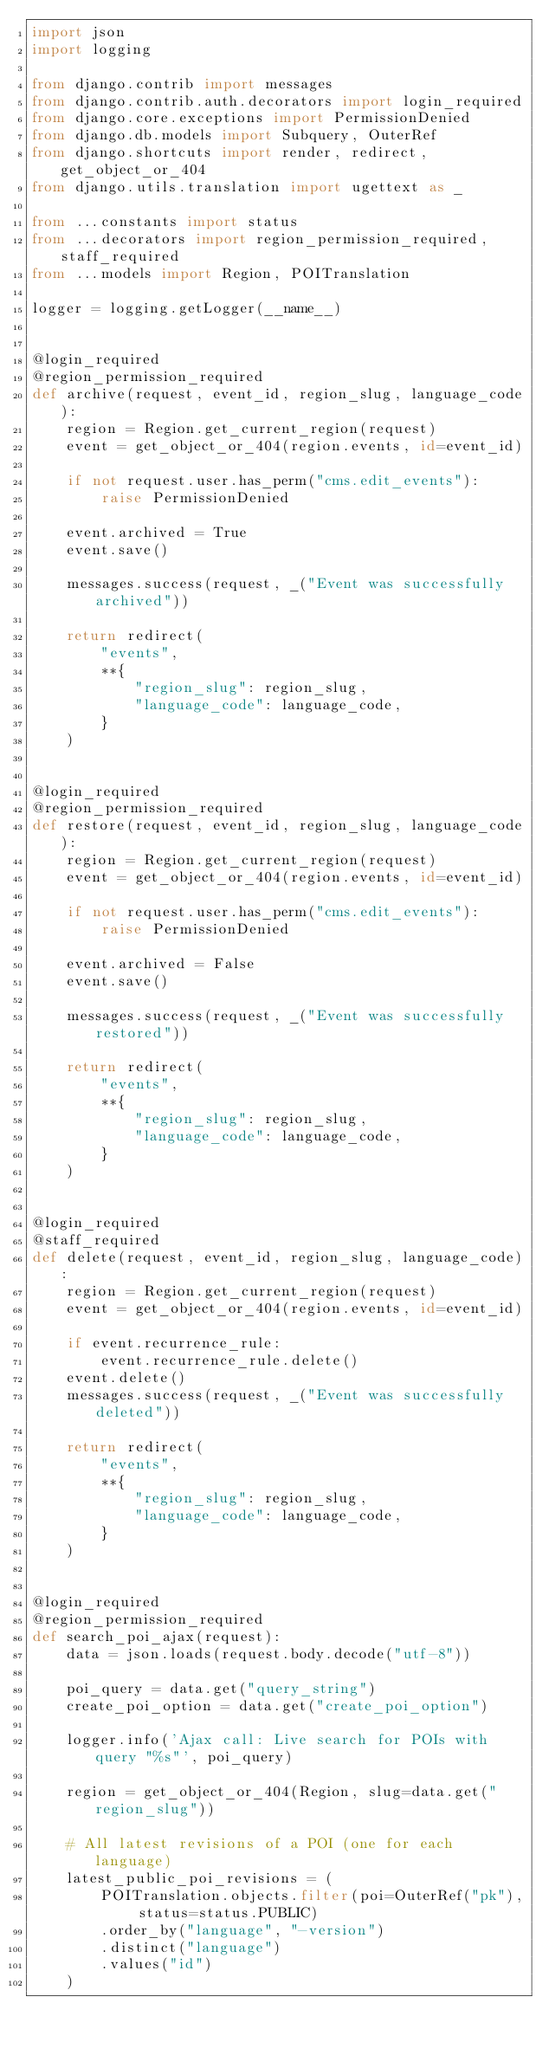<code> <loc_0><loc_0><loc_500><loc_500><_Python_>import json
import logging

from django.contrib import messages
from django.contrib.auth.decorators import login_required
from django.core.exceptions import PermissionDenied
from django.db.models import Subquery, OuterRef
from django.shortcuts import render, redirect, get_object_or_404
from django.utils.translation import ugettext as _

from ...constants import status
from ...decorators import region_permission_required, staff_required
from ...models import Region, POITranslation

logger = logging.getLogger(__name__)


@login_required
@region_permission_required
def archive(request, event_id, region_slug, language_code):
    region = Region.get_current_region(request)
    event = get_object_or_404(region.events, id=event_id)

    if not request.user.has_perm("cms.edit_events"):
        raise PermissionDenied

    event.archived = True
    event.save()

    messages.success(request, _("Event was successfully archived"))

    return redirect(
        "events",
        **{
            "region_slug": region_slug,
            "language_code": language_code,
        }
    )


@login_required
@region_permission_required
def restore(request, event_id, region_slug, language_code):
    region = Region.get_current_region(request)
    event = get_object_or_404(region.events, id=event_id)

    if not request.user.has_perm("cms.edit_events"):
        raise PermissionDenied

    event.archived = False
    event.save()

    messages.success(request, _("Event was successfully restored"))

    return redirect(
        "events",
        **{
            "region_slug": region_slug,
            "language_code": language_code,
        }
    )


@login_required
@staff_required
def delete(request, event_id, region_slug, language_code):
    region = Region.get_current_region(request)
    event = get_object_or_404(region.events, id=event_id)

    if event.recurrence_rule:
        event.recurrence_rule.delete()
    event.delete()
    messages.success(request, _("Event was successfully deleted"))

    return redirect(
        "events",
        **{
            "region_slug": region_slug,
            "language_code": language_code,
        }
    )


@login_required
@region_permission_required
def search_poi_ajax(request):
    data = json.loads(request.body.decode("utf-8"))

    poi_query = data.get("query_string")
    create_poi_option = data.get("create_poi_option")

    logger.info('Ajax call: Live search for POIs with query "%s"', poi_query)

    region = get_object_or_404(Region, slug=data.get("region_slug"))

    # All latest revisions of a POI (one for each language)
    latest_public_poi_revisions = (
        POITranslation.objects.filter(poi=OuterRef("pk"), status=status.PUBLIC)
        .order_by("language", "-version")
        .distinct("language")
        .values("id")
    )</code> 